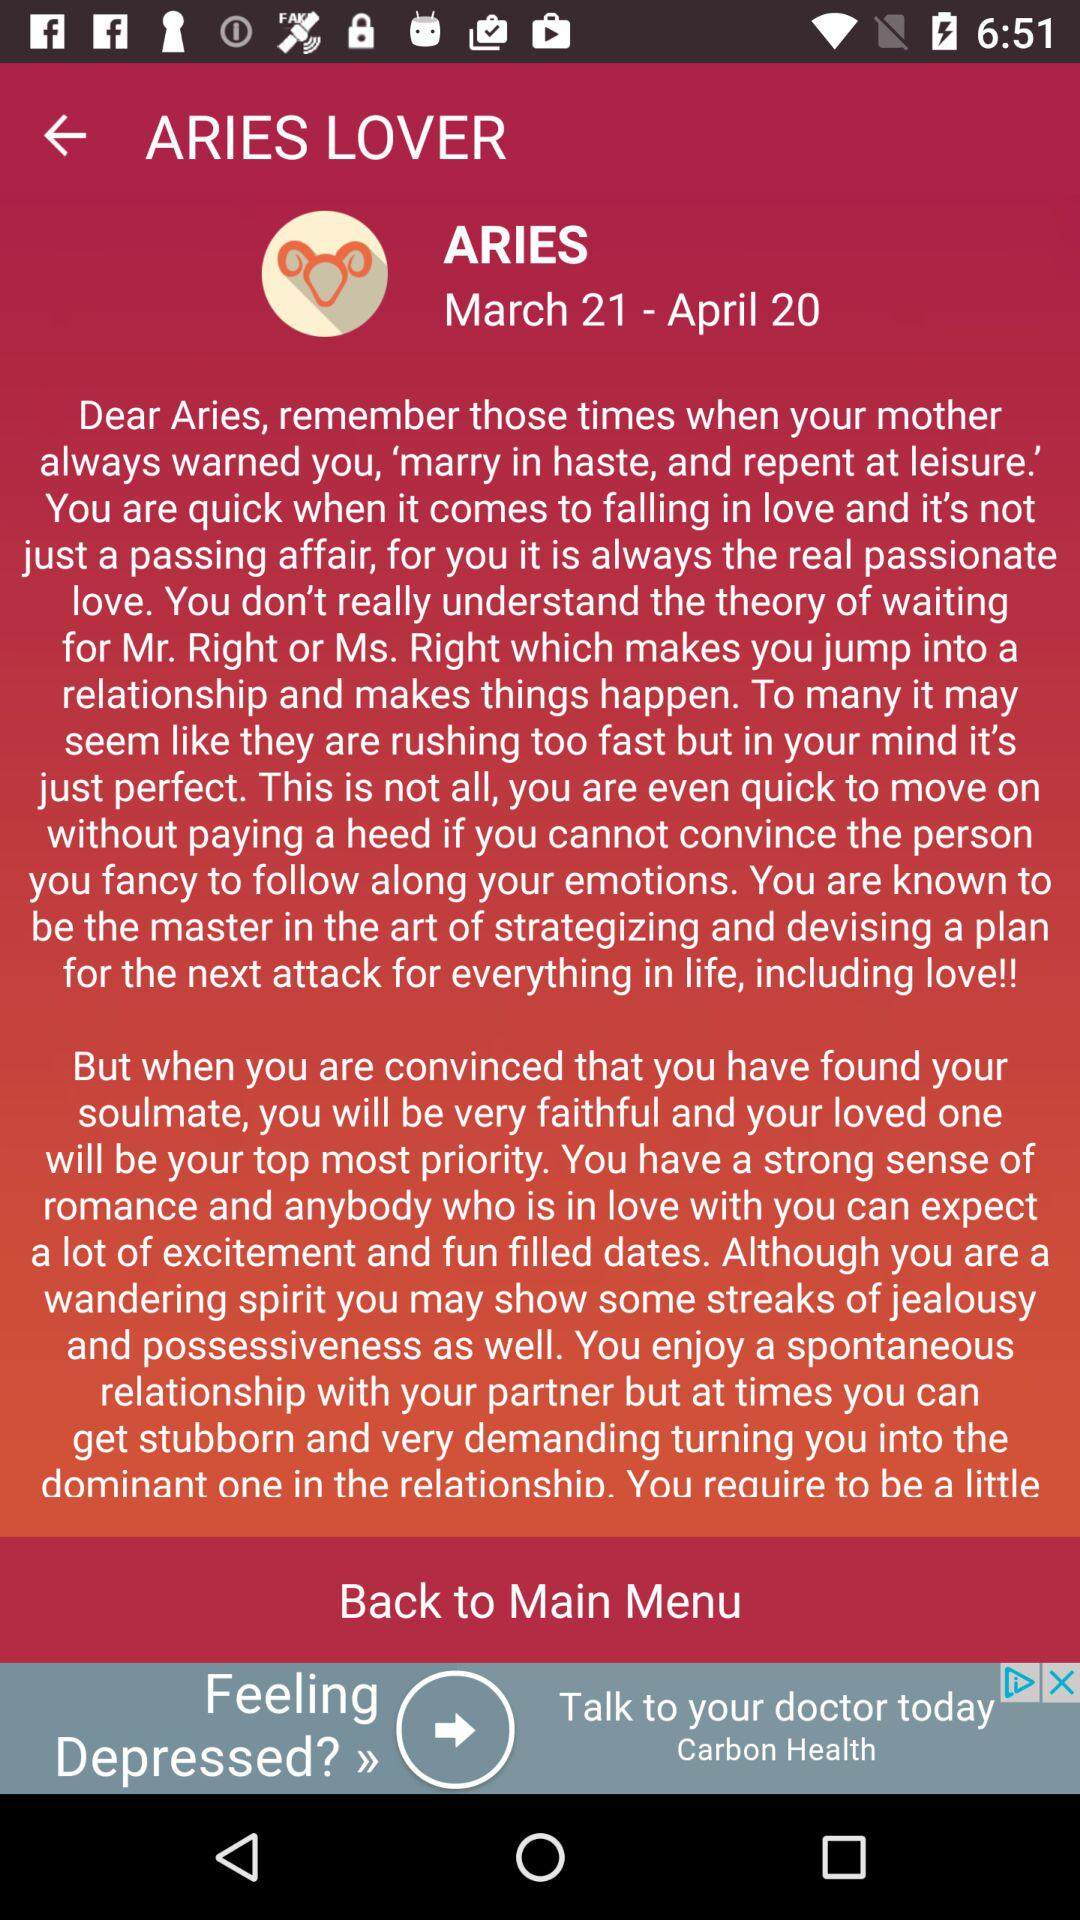People born in what month have the Aries Zodiac sign? People born between March 21 and April 20 have the Aries Zodiac sign. 